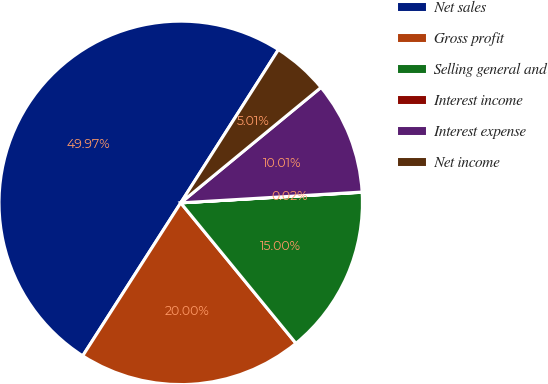Convert chart to OTSL. <chart><loc_0><loc_0><loc_500><loc_500><pie_chart><fcel>Net sales<fcel>Gross profit<fcel>Selling general and<fcel>Interest income<fcel>Interest expense<fcel>Net income<nl><fcel>49.97%<fcel>20.0%<fcel>15.0%<fcel>0.02%<fcel>10.01%<fcel>5.01%<nl></chart> 